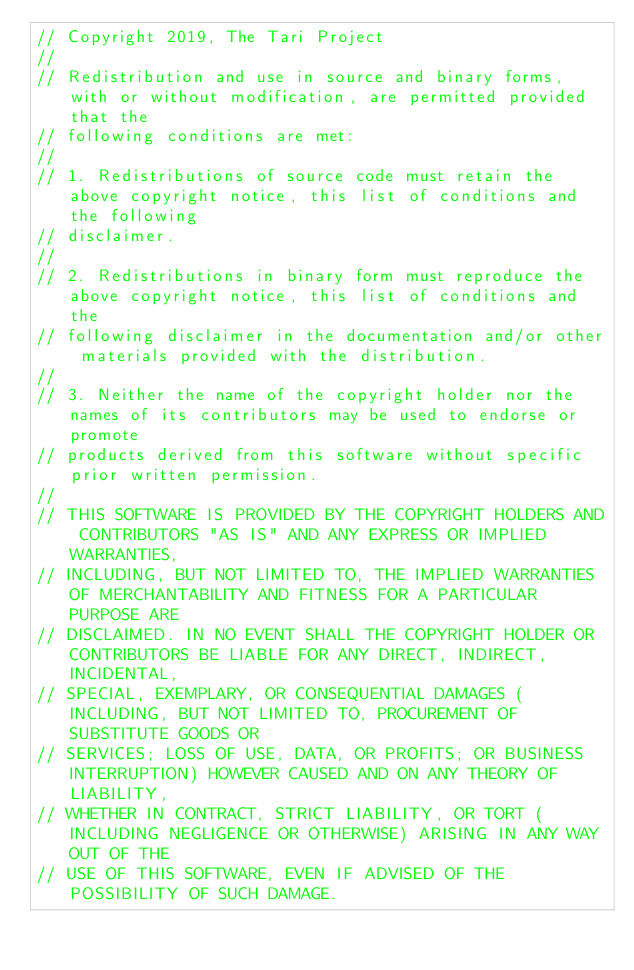<code> <loc_0><loc_0><loc_500><loc_500><_Rust_>// Copyright 2019, The Tari Project
//
// Redistribution and use in source and binary forms, with or without modification, are permitted provided that the
// following conditions are met:
//
// 1. Redistributions of source code must retain the above copyright notice, this list of conditions and the following
// disclaimer.
//
// 2. Redistributions in binary form must reproduce the above copyright notice, this list of conditions and the
// following disclaimer in the documentation and/or other materials provided with the distribution.
//
// 3. Neither the name of the copyright holder nor the names of its contributors may be used to endorse or promote
// products derived from this software without specific prior written permission.
//
// THIS SOFTWARE IS PROVIDED BY THE COPYRIGHT HOLDERS AND CONTRIBUTORS "AS IS" AND ANY EXPRESS OR IMPLIED WARRANTIES,
// INCLUDING, BUT NOT LIMITED TO, THE IMPLIED WARRANTIES OF MERCHANTABILITY AND FITNESS FOR A PARTICULAR PURPOSE ARE
// DISCLAIMED. IN NO EVENT SHALL THE COPYRIGHT HOLDER OR CONTRIBUTORS BE LIABLE FOR ANY DIRECT, INDIRECT, INCIDENTAL,
// SPECIAL, EXEMPLARY, OR CONSEQUENTIAL DAMAGES (INCLUDING, BUT NOT LIMITED TO, PROCUREMENT OF SUBSTITUTE GOODS OR
// SERVICES; LOSS OF USE, DATA, OR PROFITS; OR BUSINESS INTERRUPTION) HOWEVER CAUSED AND ON ANY THEORY OF LIABILITY,
// WHETHER IN CONTRACT, STRICT LIABILITY, OR TORT (INCLUDING NEGLIGENCE OR OTHERWISE) ARISING IN ANY WAY OUT OF THE
// USE OF THIS SOFTWARE, EVEN IF ADVISED OF THE POSSIBILITY OF SUCH DAMAGE.
</code> 